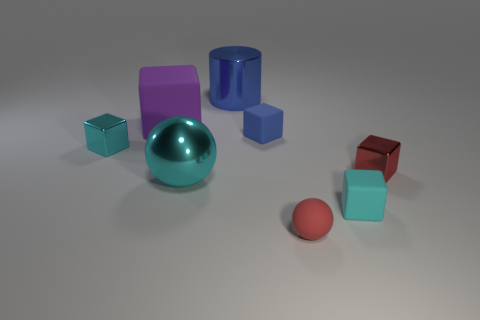Is the number of small blue things greater than the number of tiny yellow shiny cylinders?
Offer a very short reply. Yes. Is the large cyan object made of the same material as the red cube?
Your response must be concise. Yes. There is a large object that is the same material as the cylinder; what is its shape?
Ensure brevity in your answer.  Sphere. Is the number of metallic cubes less than the number of small matte objects?
Provide a short and direct response. Yes. What material is the cyan thing that is in front of the tiny cyan shiny cube and left of the small matte sphere?
Make the answer very short. Metal. How big is the cylinder behind the small shiny cube that is left of the ball in front of the large cyan ball?
Your answer should be very brief. Large. Is the shape of the purple rubber object the same as the cyan shiny thing left of the purple thing?
Your response must be concise. Yes. What number of big objects are right of the large purple matte thing and behind the small blue object?
Give a very brief answer. 1. How many red things are either small cubes or matte objects?
Your answer should be compact. 2. Does the tiny block that is left of the blue block have the same color as the rubber block right of the tiny red sphere?
Ensure brevity in your answer.  Yes. 